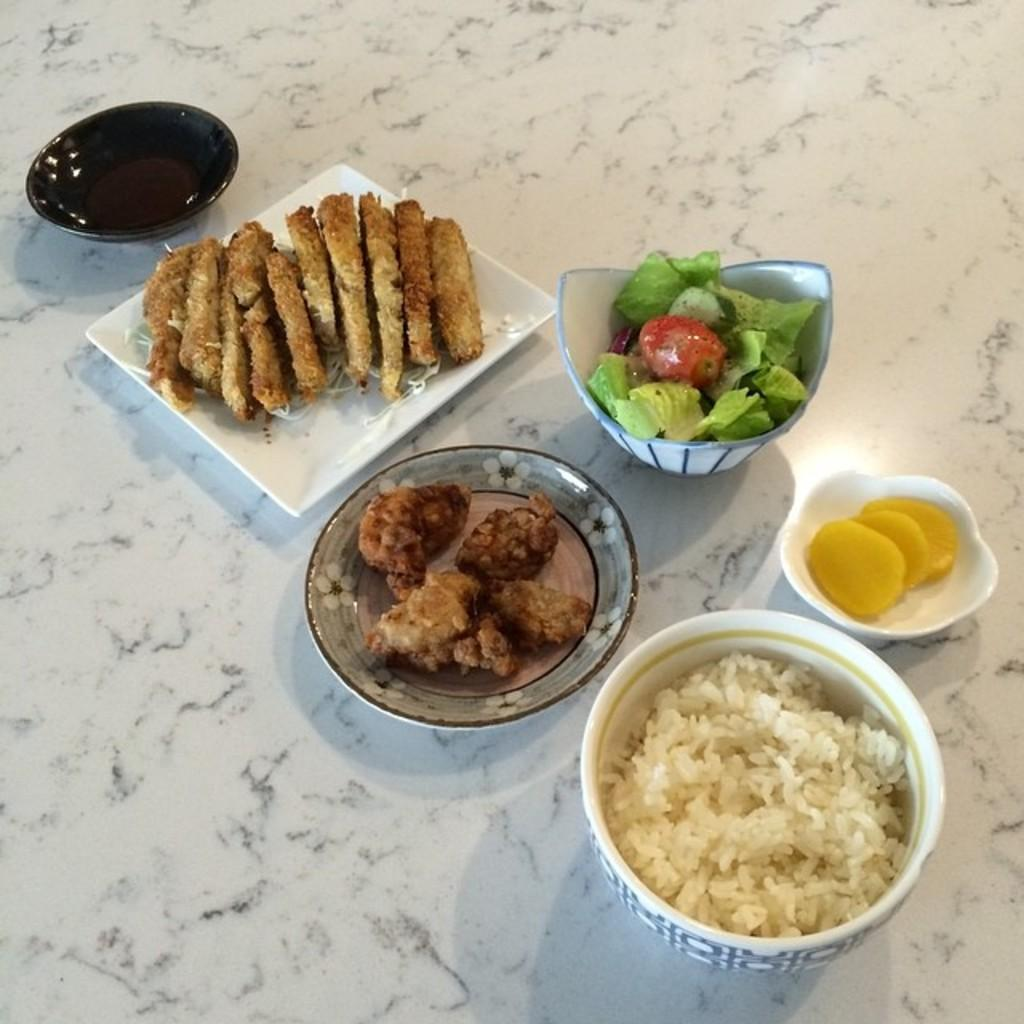What types of tableware are visible in the image? There are plates and bowls in the image. Can you describe the variety of dishes in the image? There are different types of dishes visible in the image. What is the trick behind the development of these dishes in the image? There is no trick or development process mentioned in the image; it simply shows various dishes, plates, and bowls. 